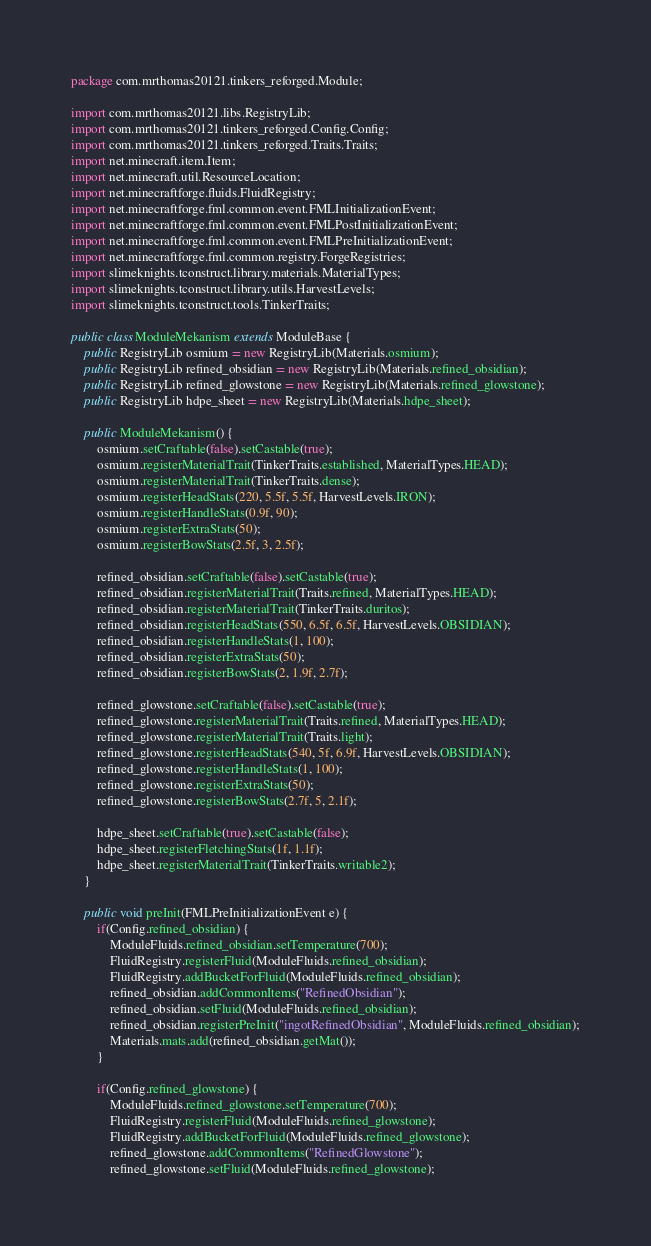Convert code to text. <code><loc_0><loc_0><loc_500><loc_500><_Java_>package com.mrthomas20121.tinkers_reforged.Module;

import com.mrthomas20121.libs.RegistryLib;
import com.mrthomas20121.tinkers_reforged.Config.Config;
import com.mrthomas20121.tinkers_reforged.Traits.Traits;
import net.minecraft.item.Item;
import net.minecraft.util.ResourceLocation;
import net.minecraftforge.fluids.FluidRegistry;
import net.minecraftforge.fml.common.event.FMLInitializationEvent;
import net.minecraftforge.fml.common.event.FMLPostInitializationEvent;
import net.minecraftforge.fml.common.event.FMLPreInitializationEvent;
import net.minecraftforge.fml.common.registry.ForgeRegistries;
import slimeknights.tconstruct.library.materials.MaterialTypes;
import slimeknights.tconstruct.library.utils.HarvestLevels;
import slimeknights.tconstruct.tools.TinkerTraits;

public class ModuleMekanism extends ModuleBase {
    public RegistryLib osmium = new RegistryLib(Materials.osmium);
    public RegistryLib refined_obsidian = new RegistryLib(Materials.refined_obsidian);
    public RegistryLib refined_glowstone = new RegistryLib(Materials.refined_glowstone);
    public RegistryLib hdpe_sheet = new RegistryLib(Materials.hdpe_sheet);

    public ModuleMekanism() {
        osmium.setCraftable(false).setCastable(true);
        osmium.registerMaterialTrait(TinkerTraits.established, MaterialTypes.HEAD);
        osmium.registerMaterialTrait(TinkerTraits.dense);
        osmium.registerHeadStats(220, 5.5f, 5.5f, HarvestLevels.IRON);
        osmium.registerHandleStats(0.9f, 90);
        osmium.registerExtraStats(50);
        osmium.registerBowStats(2.5f, 3, 2.5f);

        refined_obsidian.setCraftable(false).setCastable(true);
        refined_obsidian.registerMaterialTrait(Traits.refined, MaterialTypes.HEAD);
        refined_obsidian.registerMaterialTrait(TinkerTraits.duritos);
        refined_obsidian.registerHeadStats(550, 6.5f, 6.5f, HarvestLevels.OBSIDIAN);
        refined_obsidian.registerHandleStats(1, 100);
        refined_obsidian.registerExtraStats(50);
        refined_obsidian.registerBowStats(2, 1.9f, 2.7f);

        refined_glowstone.setCraftable(false).setCastable(true);
        refined_glowstone.registerMaterialTrait(Traits.refined, MaterialTypes.HEAD);
        refined_glowstone.registerMaterialTrait(Traits.light);
        refined_glowstone.registerHeadStats(540, 5f, 6.9f, HarvestLevels.OBSIDIAN);
        refined_glowstone.registerHandleStats(1, 100);
        refined_glowstone.registerExtraStats(50);
        refined_glowstone.registerBowStats(2.7f, 5, 2.1f);

        hdpe_sheet.setCraftable(true).setCastable(false);
        hdpe_sheet.registerFletchingStats(1f, 1.1f);
        hdpe_sheet.registerMaterialTrait(TinkerTraits.writable2);
    }

    public void preInit(FMLPreInitializationEvent e) {
        if(Config.refined_obsidian) {
            ModuleFluids.refined_obsidian.setTemperature(700);
            FluidRegistry.registerFluid(ModuleFluids.refined_obsidian);
            FluidRegistry.addBucketForFluid(ModuleFluids.refined_obsidian);
            refined_obsidian.addCommonItems("RefinedObsidian");
            refined_obsidian.setFluid(ModuleFluids.refined_obsidian);
            refined_obsidian.registerPreInit("ingotRefinedObsidian", ModuleFluids.refined_obsidian);
            Materials.mats.add(refined_obsidian.getMat());
        }

        if(Config.refined_glowstone) {
            ModuleFluids.refined_glowstone.setTemperature(700);
            FluidRegistry.registerFluid(ModuleFluids.refined_glowstone);
            FluidRegistry.addBucketForFluid(ModuleFluids.refined_glowstone);
            refined_glowstone.addCommonItems("RefinedGlowstone");
            refined_glowstone.setFluid(ModuleFluids.refined_glowstone);</code> 